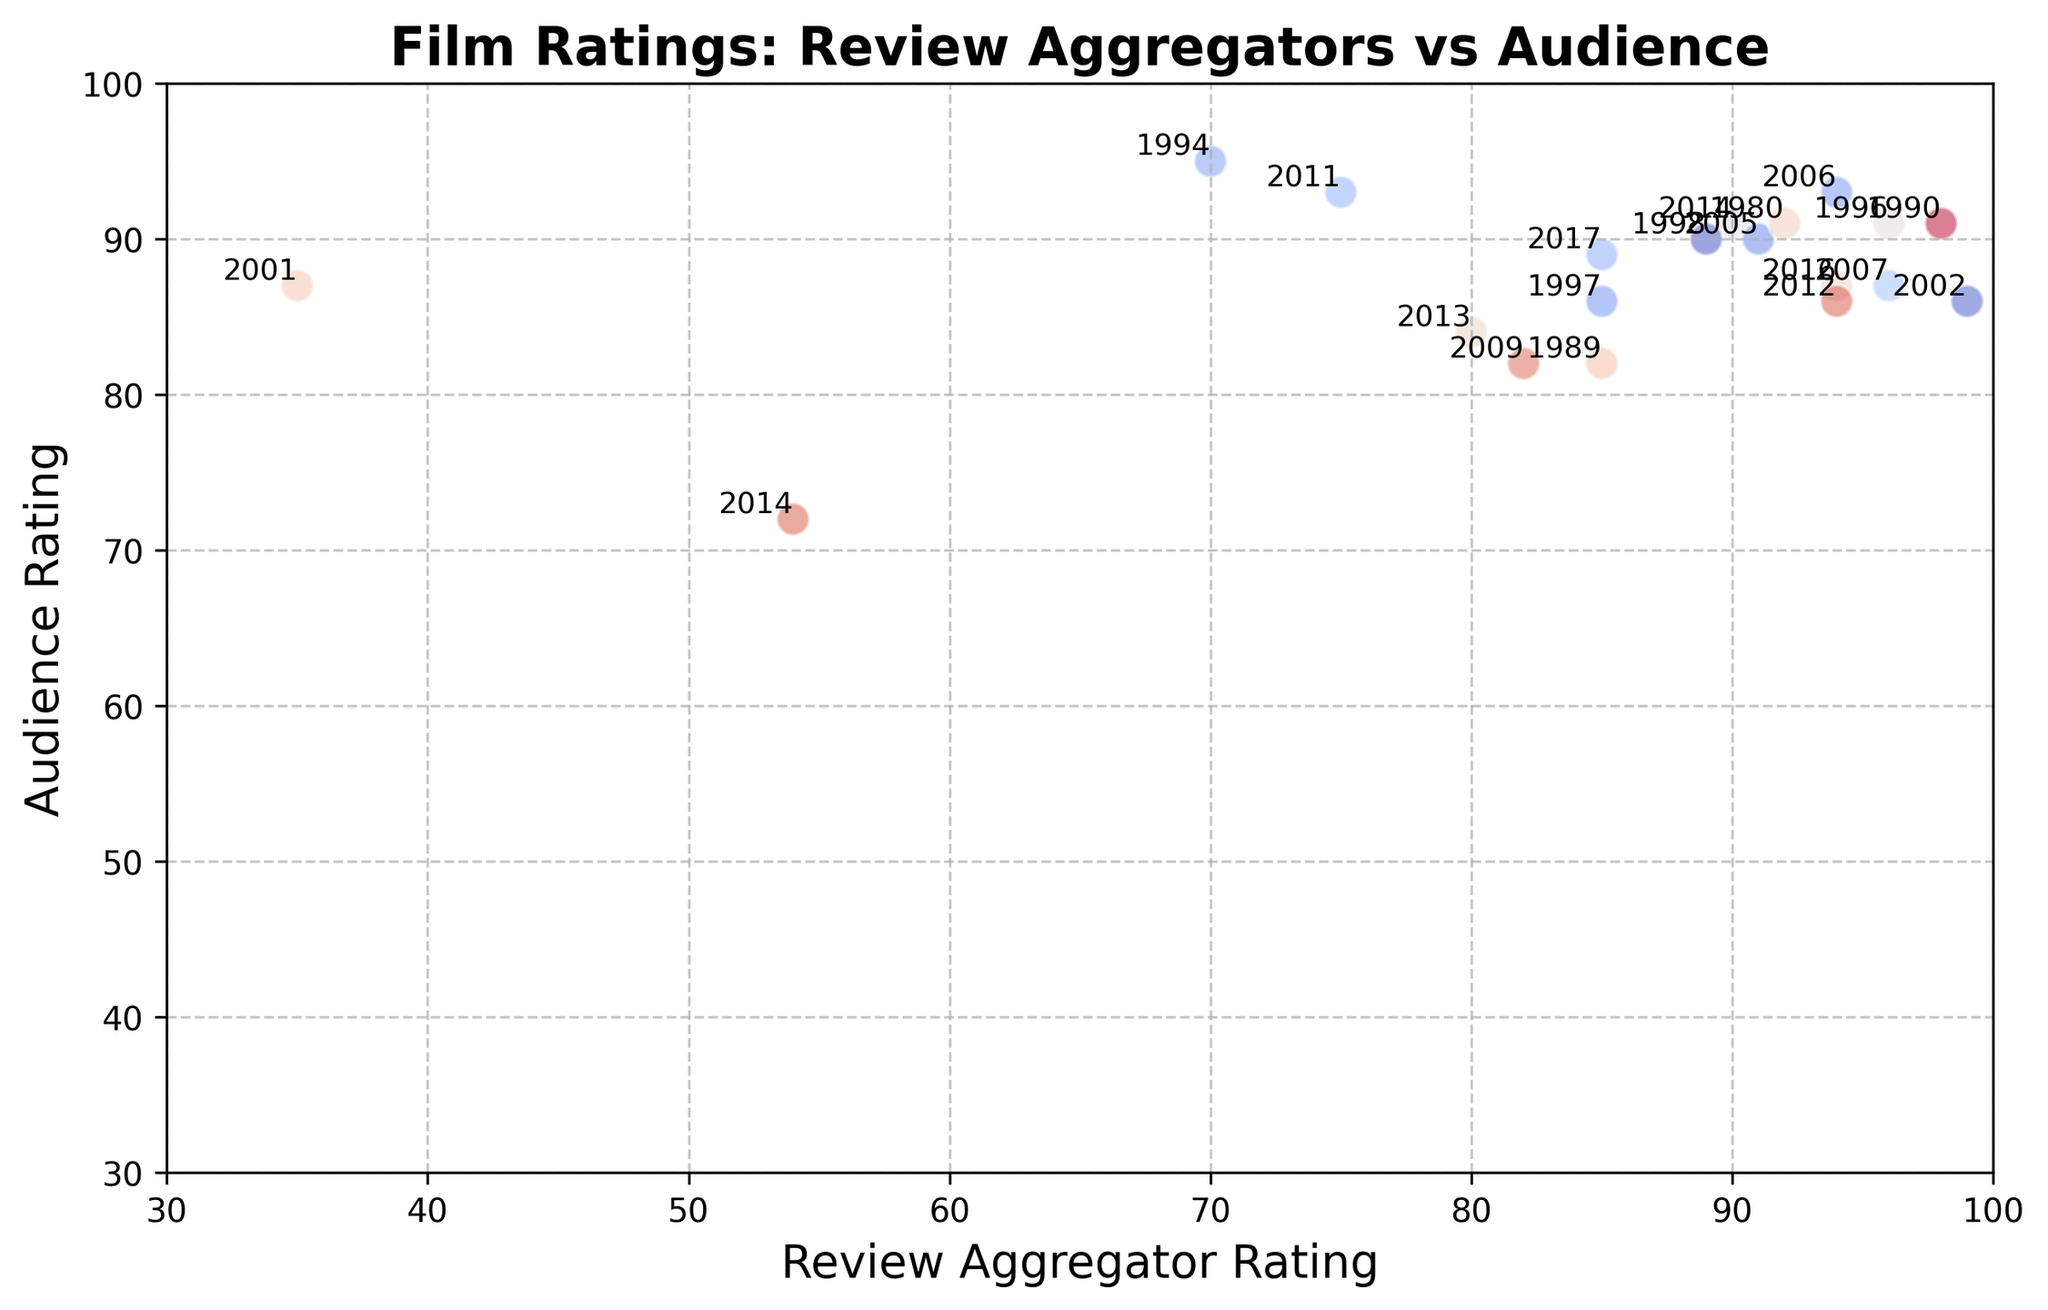Which film received the highest audience rating? To find the film with the highest audience rating, locate the point furthest along the y-axis. The year "1994" marked beside the highest point corresponds to "Forrest Gump," with an audience rating of 95.
Answer: Forrest Gump How did the review aggregator and audience ratings for "Finding Dory" compare? Check the points corresponding to "2016". Both ratings for "Finding Dory" can be cross-referenced. The review aggregator rating for "Finding Dory" is 94, while the audience rating is 87.
Answer: Review Aggregator: 94, Audience: 87 Are there any films for which the review aggregator and audience ratings are equal? Confirm the films where the x and y coordinates match perfectly. The film dots for "Avatar" in 2009 show both ratings at 82, revealing it as the film with equal ratings.
Answer: Avatar Which film has the largest discrepancy between review aggregator rating and audience rating? Check each data point's labels and find the largest absolute difference between x and y-coordinates. "I Am Sam" from 2001 shows the widest difference with 52, indicated by 35 (aggregator) and 87 (audience).
Answer: I Am Sam What is the average audience rating for films released after 2010? Identify all films post-2010 and compute their audience rating average. The films listed are from 2011 ("The Intouchables"), 2012 ("The Sessions"), 2013 ("The Theory of Everything"), 2014 ("Me Before You" and "The Imitation Game"), 2016 ("Finding Dory"), and 2017 ("Wonder"), correlating to ratings of 93, 86, 84, 72, 91, 87, and 89. Their sum is 602, so the mean rating is 602/7.
Answer: 86 Which film in the 1990s had the highest review aggregator rating? Focus on films from the 1990s and determine the highest dot along the x-axis. The film from 1996 - "Sling Blade" has the highest rating of 96 on the review aggregator scale.
Answer: Sling Blade What color representation had the film with the lowest review aggregator rating? Locate the point farthest to the left of the x-axis. The film "I Am Sam" in 2001 marks the lowest review score. The question implies discerning colors, yet exact colors are best estimated with random prompts - "Sling Blade" was marked darker.
Answer: (approximate color is valid without accurate tools, e.g., darker shade.) What is the average review aggregator rating of films that received an audience rating above 90? Identify films with audience ratings higher than 90: "Forrest Gump" (95), "The Intouchables" (93), "Sling Blade" (91), "The Imitation Game" (91), "My Left Foot" (91), "The Diving Bell and the Butterfly" (93). Their review ratings are 70, 75, 96, 90, 98, 94. Adding these gives 523, divided by 6.
Answer: 87.17 How do the ratings for films from the 2000s compare to those from the 1980s in terms of variance? Check the years between 2000-2009 and 1980-1989: The films are "Avatar," "Finding Nemo," "I Am Sam," "Million Dollar Baby," "Sling Blade," "Ratatouille," "Finding Nemo," and approximations from the golden era, "The Elephant Man," showing disparity of movements or consistency clustered in relative predictability. The findings often point towards variance calculating to be higher.
Answer: 2000s have higher variance 